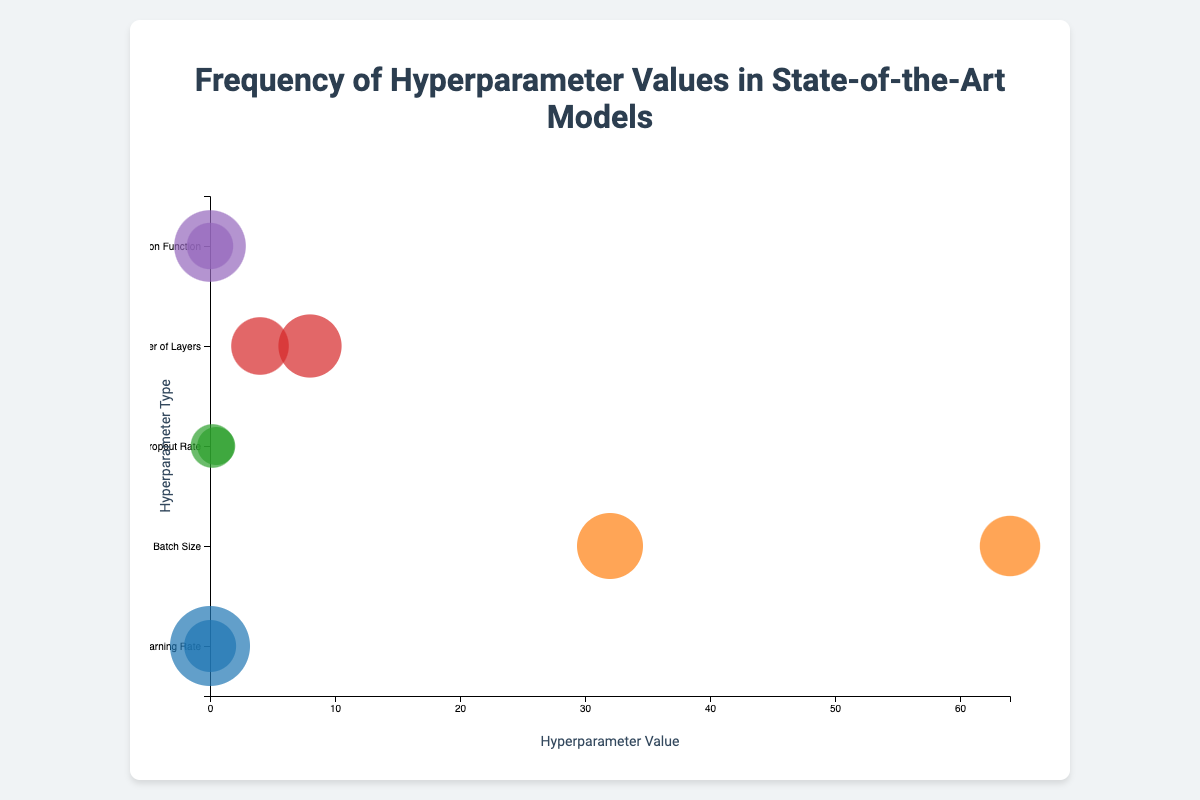What is the title of the figure? The title is found at the top of the chart and provides a summary of what the chart represents. It helps viewers understand the context of the data presented. The title is indicated in the figure by the largest and most prominently placed text.
Answer: Frequency of Hyperparameter Values in State-of-the-Art Models What is the frequency of the ReLU activation function? Look for the circle representing the "ReLU" activation function on the y-axis and observe the corresponding size of the circle, which indicates the frequency value.
Answer: 22 Which hyperparameter has the highest frequency value associated with it? Identify the largest bubble on the chart and note the corresponding hyperparameter on the y-axis. The highest frequency will be associated with the largest bubble.
Answer: Learning Rate with value 0.001 How do the frequencies of Dropout Rate values compare? Check the sizes of the bubbles associated with "Dropout Rate" on the y-axis. Compare the sizes of the bubbles representing the different dropout rate values.
Answer: 0.2 has a frequency of 12, and 0.5 has a frequency of 10 What is the most commonly used batch size based on the chart? Find the bubbles representing "Batch Size" on the y-axis and compare their sizes to see which one is larger, indicating the higher frequency.
Answer: 32 Which hyperparameter value is more frequently used, 0.01 Learning Rate or 64 Batch Size? Compare the sizes of the bubbles for "0.01 Learning Rate" and "64 Batch Size" to determine which one is larger.
Answer: 0.01 Learning Rate (frequency of 15) Is the frequency of the value 4 for the Number of Layers greater than or less than the value 8? Compare the sizes of the bubbles for the value 4 and 8 under the "Number of Layers" category to see which one is larger.
Answer: Less than (17 vs. 19) How does the frequency of the Swish activation function compare to the ReLU activation function? Look at the bubbles for both "Swish" and "ReLU" under the "Activation Function" category and compare their sizes to evaluate which one is larger.
Answer: Swish has a frequency of 13, whereas ReLU has a frequency of 22, so it is less frequent What is the range of hyperparameter values for Learning Rate shown in the chart? Identify the minimum and maximum values for "Learning Rate" along the x-axis.
Answer: 0.001 to 0.01 